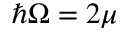<formula> <loc_0><loc_0><loc_500><loc_500>\hbar { \Omega } = 2 \mu</formula> 